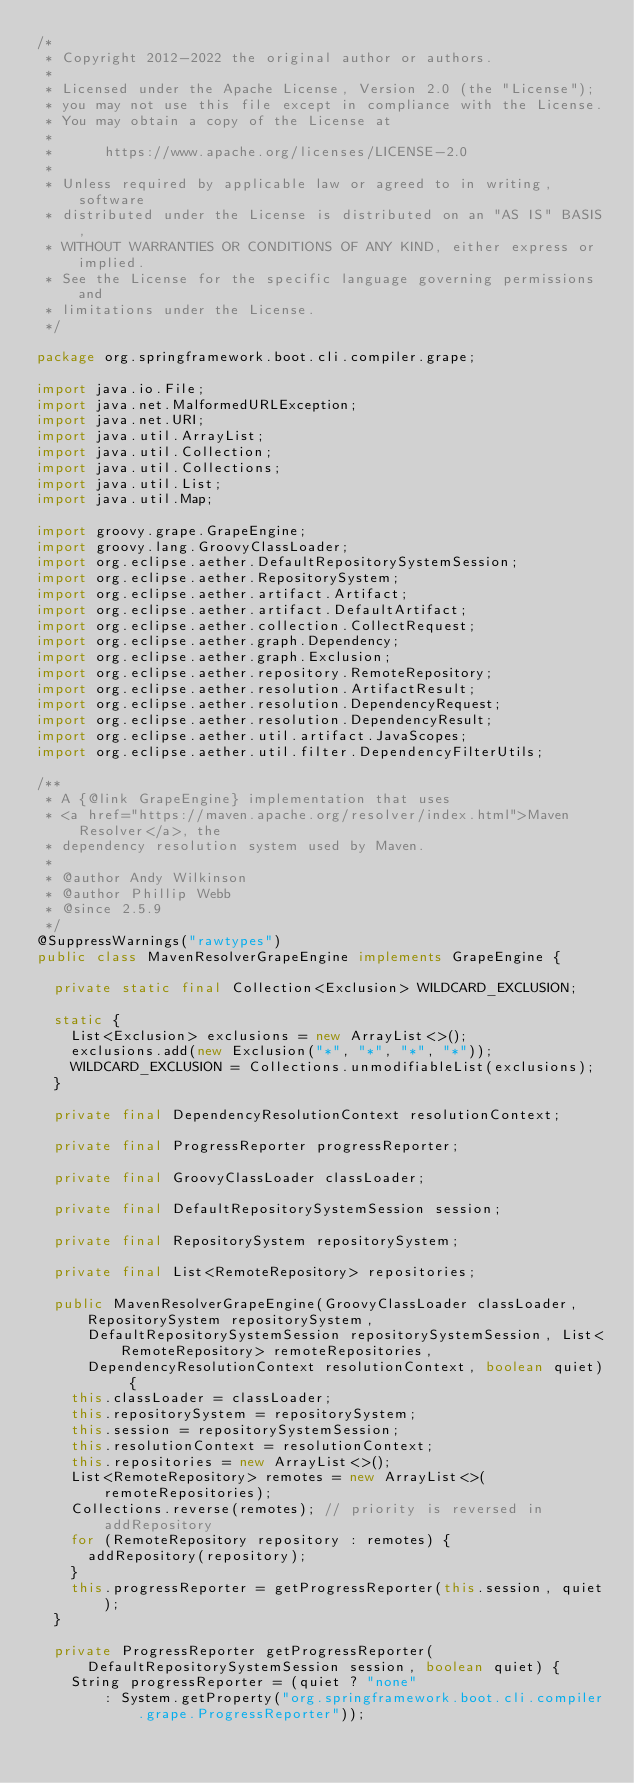<code> <loc_0><loc_0><loc_500><loc_500><_Java_>/*
 * Copyright 2012-2022 the original author or authors.
 *
 * Licensed under the Apache License, Version 2.0 (the "License");
 * you may not use this file except in compliance with the License.
 * You may obtain a copy of the License at
 *
 *      https://www.apache.org/licenses/LICENSE-2.0
 *
 * Unless required by applicable law or agreed to in writing, software
 * distributed under the License is distributed on an "AS IS" BASIS,
 * WITHOUT WARRANTIES OR CONDITIONS OF ANY KIND, either express or implied.
 * See the License for the specific language governing permissions and
 * limitations under the License.
 */

package org.springframework.boot.cli.compiler.grape;

import java.io.File;
import java.net.MalformedURLException;
import java.net.URI;
import java.util.ArrayList;
import java.util.Collection;
import java.util.Collections;
import java.util.List;
import java.util.Map;

import groovy.grape.GrapeEngine;
import groovy.lang.GroovyClassLoader;
import org.eclipse.aether.DefaultRepositorySystemSession;
import org.eclipse.aether.RepositorySystem;
import org.eclipse.aether.artifact.Artifact;
import org.eclipse.aether.artifact.DefaultArtifact;
import org.eclipse.aether.collection.CollectRequest;
import org.eclipse.aether.graph.Dependency;
import org.eclipse.aether.graph.Exclusion;
import org.eclipse.aether.repository.RemoteRepository;
import org.eclipse.aether.resolution.ArtifactResult;
import org.eclipse.aether.resolution.DependencyRequest;
import org.eclipse.aether.resolution.DependencyResult;
import org.eclipse.aether.util.artifact.JavaScopes;
import org.eclipse.aether.util.filter.DependencyFilterUtils;

/**
 * A {@link GrapeEngine} implementation that uses
 * <a href="https://maven.apache.org/resolver/index.html">Maven Resolver</a>, the
 * dependency resolution system used by Maven.
 *
 * @author Andy Wilkinson
 * @author Phillip Webb
 * @since 2.5.9
 */
@SuppressWarnings("rawtypes")
public class MavenResolverGrapeEngine implements GrapeEngine {

	private static final Collection<Exclusion> WILDCARD_EXCLUSION;

	static {
		List<Exclusion> exclusions = new ArrayList<>();
		exclusions.add(new Exclusion("*", "*", "*", "*"));
		WILDCARD_EXCLUSION = Collections.unmodifiableList(exclusions);
	}

	private final DependencyResolutionContext resolutionContext;

	private final ProgressReporter progressReporter;

	private final GroovyClassLoader classLoader;

	private final DefaultRepositorySystemSession session;

	private final RepositorySystem repositorySystem;

	private final List<RemoteRepository> repositories;

	public MavenResolverGrapeEngine(GroovyClassLoader classLoader, RepositorySystem repositorySystem,
			DefaultRepositorySystemSession repositorySystemSession, List<RemoteRepository> remoteRepositories,
			DependencyResolutionContext resolutionContext, boolean quiet) {
		this.classLoader = classLoader;
		this.repositorySystem = repositorySystem;
		this.session = repositorySystemSession;
		this.resolutionContext = resolutionContext;
		this.repositories = new ArrayList<>();
		List<RemoteRepository> remotes = new ArrayList<>(remoteRepositories);
		Collections.reverse(remotes); // priority is reversed in addRepository
		for (RemoteRepository repository : remotes) {
			addRepository(repository);
		}
		this.progressReporter = getProgressReporter(this.session, quiet);
	}

	private ProgressReporter getProgressReporter(DefaultRepositorySystemSession session, boolean quiet) {
		String progressReporter = (quiet ? "none"
				: System.getProperty("org.springframework.boot.cli.compiler.grape.ProgressReporter"));</code> 